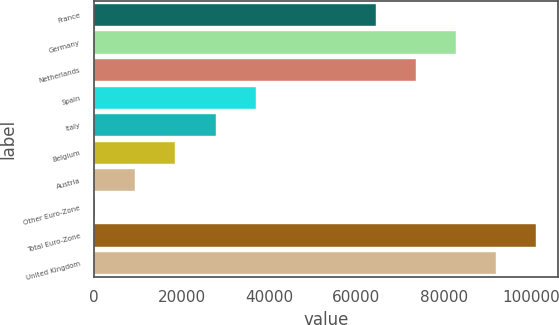Convert chart to OTSL. <chart><loc_0><loc_0><loc_500><loc_500><bar_chart><fcel>France<fcel>Germany<fcel>Netherlands<fcel>Spain<fcel>Italy<fcel>Belgium<fcel>Austria<fcel>Other Euro-Zone<fcel>Total Euro-Zone<fcel>United Kingdom<nl><fcel>64467.5<fcel>82814.5<fcel>73641<fcel>36947<fcel>27773.5<fcel>18600<fcel>9426.5<fcel>253<fcel>101162<fcel>91988<nl></chart> 